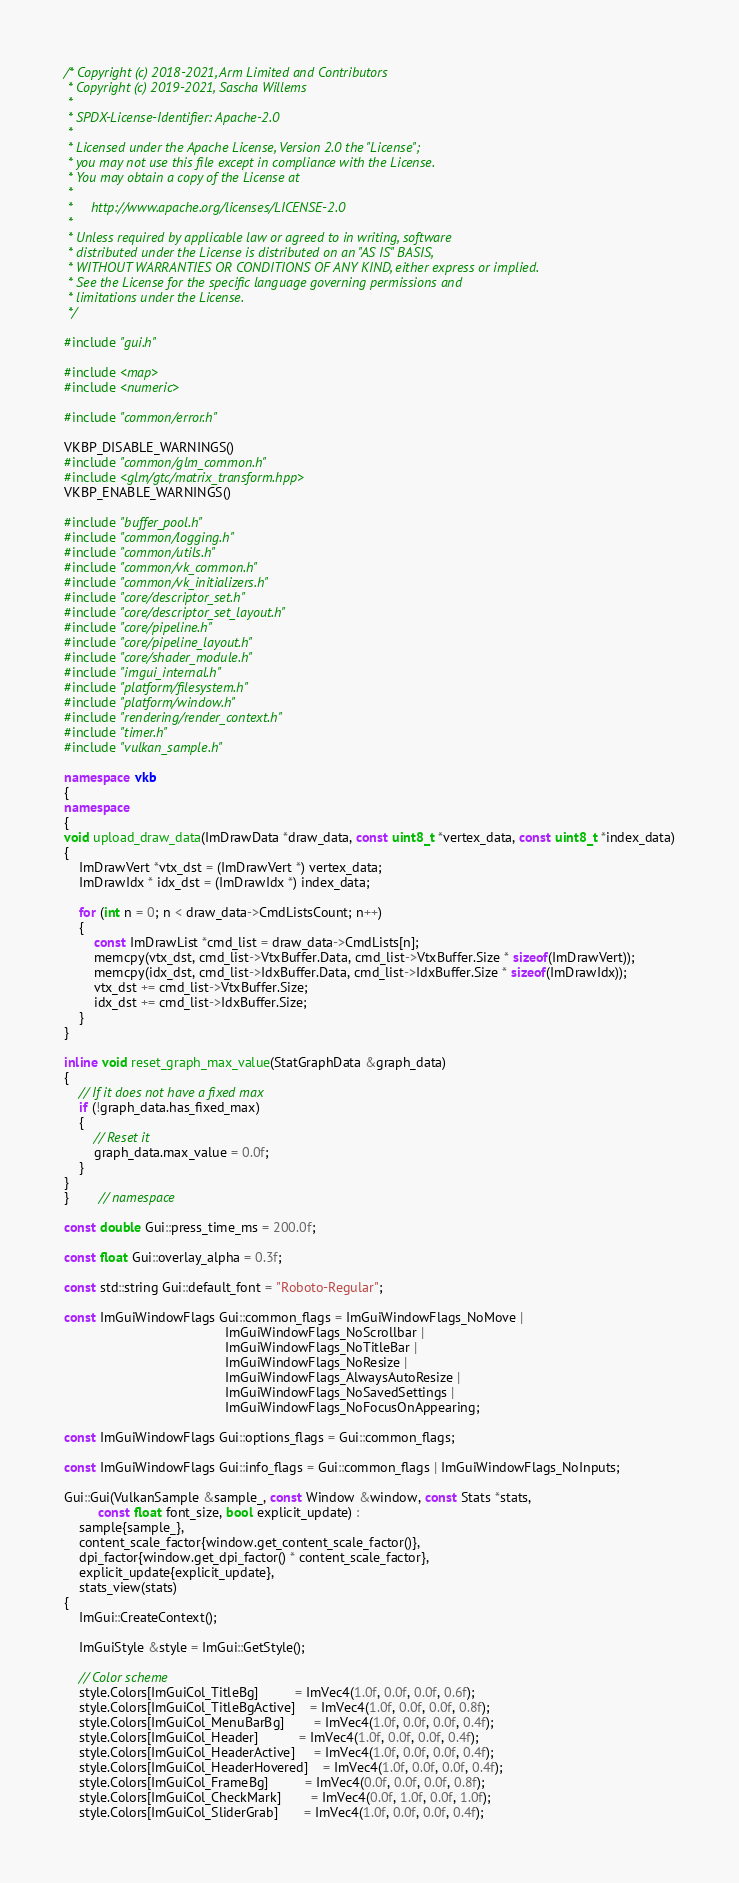<code> <loc_0><loc_0><loc_500><loc_500><_C++_>/* Copyright (c) 2018-2021, Arm Limited and Contributors
 * Copyright (c) 2019-2021, Sascha Willems
 *
 * SPDX-License-Identifier: Apache-2.0
 *
 * Licensed under the Apache License, Version 2.0 the "License";
 * you may not use this file except in compliance with the License.
 * You may obtain a copy of the License at
 *
 *     http://www.apache.org/licenses/LICENSE-2.0
 *
 * Unless required by applicable law or agreed to in writing, software
 * distributed under the License is distributed on an "AS IS" BASIS,
 * WITHOUT WARRANTIES OR CONDITIONS OF ANY KIND, either express or implied.
 * See the License for the specific language governing permissions and
 * limitations under the License.
 */

#include "gui.h"

#include <map>
#include <numeric>

#include "common/error.h"

VKBP_DISABLE_WARNINGS()
#include "common/glm_common.h"
#include <glm/gtc/matrix_transform.hpp>
VKBP_ENABLE_WARNINGS()

#include "buffer_pool.h"
#include "common/logging.h"
#include "common/utils.h"
#include "common/vk_common.h"
#include "common/vk_initializers.h"
#include "core/descriptor_set.h"
#include "core/descriptor_set_layout.h"
#include "core/pipeline.h"
#include "core/pipeline_layout.h"
#include "core/shader_module.h"
#include "imgui_internal.h"
#include "platform/filesystem.h"
#include "platform/window.h"
#include "rendering/render_context.h"
#include "timer.h"
#include "vulkan_sample.h"

namespace vkb
{
namespace
{
void upload_draw_data(ImDrawData *draw_data, const uint8_t *vertex_data, const uint8_t *index_data)
{
	ImDrawVert *vtx_dst = (ImDrawVert *) vertex_data;
	ImDrawIdx * idx_dst = (ImDrawIdx *) index_data;

	for (int n = 0; n < draw_data->CmdListsCount; n++)
	{
		const ImDrawList *cmd_list = draw_data->CmdLists[n];
		memcpy(vtx_dst, cmd_list->VtxBuffer.Data, cmd_list->VtxBuffer.Size * sizeof(ImDrawVert));
		memcpy(idx_dst, cmd_list->IdxBuffer.Data, cmd_list->IdxBuffer.Size * sizeof(ImDrawIdx));
		vtx_dst += cmd_list->VtxBuffer.Size;
		idx_dst += cmd_list->IdxBuffer.Size;
	}
}

inline void reset_graph_max_value(StatGraphData &graph_data)
{
	// If it does not have a fixed max
	if (!graph_data.has_fixed_max)
	{
		// Reset it
		graph_data.max_value = 0.0f;
	}
}
}        // namespace

const double Gui::press_time_ms = 200.0f;

const float Gui::overlay_alpha = 0.3f;

const std::string Gui::default_font = "Roboto-Regular";

const ImGuiWindowFlags Gui::common_flags = ImGuiWindowFlags_NoMove |
                                           ImGuiWindowFlags_NoScrollbar |
                                           ImGuiWindowFlags_NoTitleBar |
                                           ImGuiWindowFlags_NoResize |
                                           ImGuiWindowFlags_AlwaysAutoResize |
                                           ImGuiWindowFlags_NoSavedSettings |
                                           ImGuiWindowFlags_NoFocusOnAppearing;

const ImGuiWindowFlags Gui::options_flags = Gui::common_flags;

const ImGuiWindowFlags Gui::info_flags = Gui::common_flags | ImGuiWindowFlags_NoInputs;

Gui::Gui(VulkanSample &sample_, const Window &window, const Stats *stats,
         const float font_size, bool explicit_update) :
    sample{sample_},
    content_scale_factor{window.get_content_scale_factor()},
    dpi_factor{window.get_dpi_factor() * content_scale_factor},
    explicit_update{explicit_update},
    stats_view(stats)
{
	ImGui::CreateContext();

	ImGuiStyle &style = ImGui::GetStyle();

	// Color scheme
	style.Colors[ImGuiCol_TitleBg]          = ImVec4(1.0f, 0.0f, 0.0f, 0.6f);
	style.Colors[ImGuiCol_TitleBgActive]    = ImVec4(1.0f, 0.0f, 0.0f, 0.8f);
	style.Colors[ImGuiCol_MenuBarBg]        = ImVec4(1.0f, 0.0f, 0.0f, 0.4f);
	style.Colors[ImGuiCol_Header]           = ImVec4(1.0f, 0.0f, 0.0f, 0.4f);
	style.Colors[ImGuiCol_HeaderActive]     = ImVec4(1.0f, 0.0f, 0.0f, 0.4f);
	style.Colors[ImGuiCol_HeaderHovered]    = ImVec4(1.0f, 0.0f, 0.0f, 0.4f);
	style.Colors[ImGuiCol_FrameBg]          = ImVec4(0.0f, 0.0f, 0.0f, 0.8f);
	style.Colors[ImGuiCol_CheckMark]        = ImVec4(0.0f, 1.0f, 0.0f, 1.0f);
	style.Colors[ImGuiCol_SliderGrab]       = ImVec4(1.0f, 0.0f, 0.0f, 0.4f);</code> 